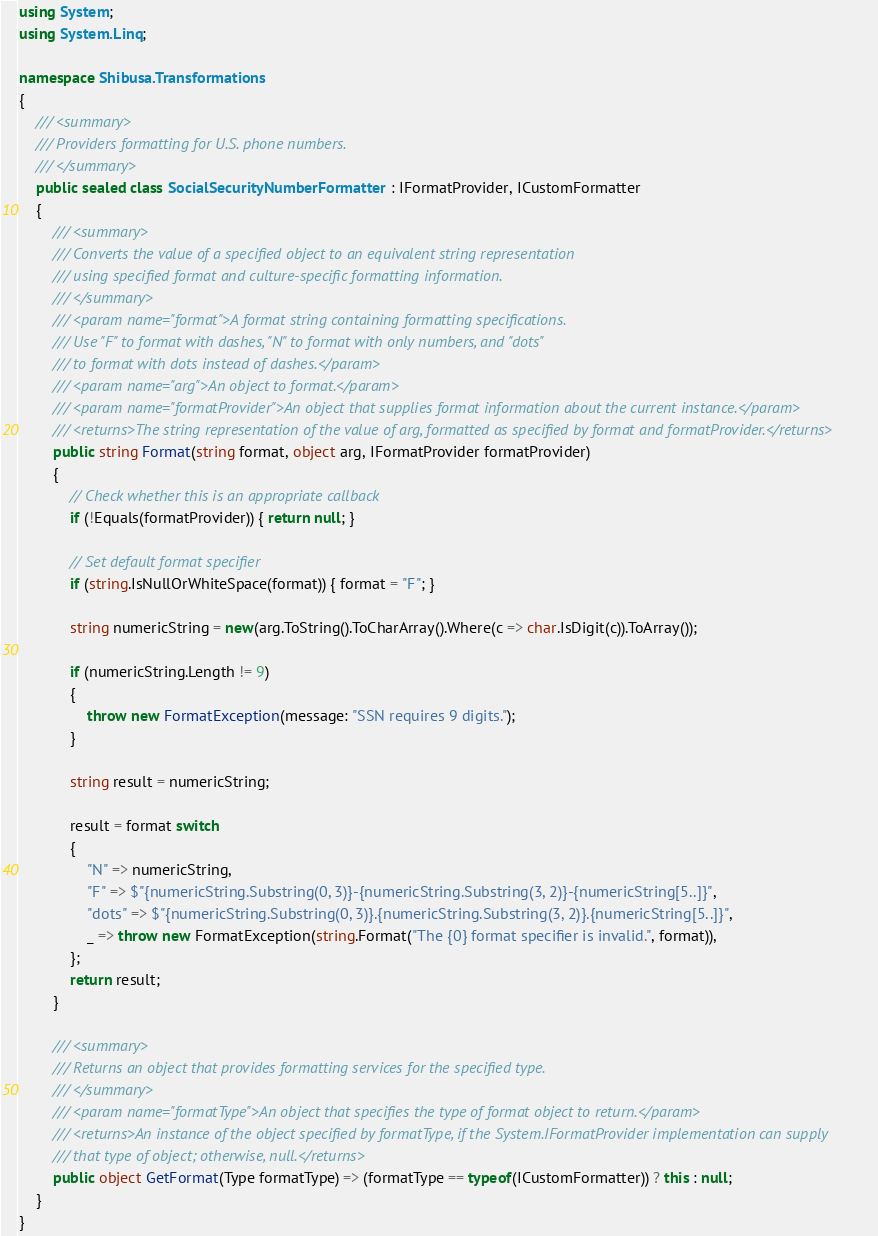<code> <loc_0><loc_0><loc_500><loc_500><_C#_>using System;
using System.Linq;

namespace Shibusa.Transformations
{
    /// <summary>
    /// Providers formatting for U.S. phone numbers.
    /// </summary>
    public sealed class SocialSecurityNumberFormatter : IFormatProvider, ICustomFormatter
    {
        /// <summary>
        /// Converts the value of a specified object to an equivalent string representation 
        /// using specified format and culture-specific formatting information.
        /// </summary>
        /// <param name="format">A format string containing formatting specifications.
        /// Use "F" to format with dashes, "N" to format with only numbers, and "dots"
        /// to format with dots instead of dashes.</param>
        /// <param name="arg">An object to format.</param>
        /// <param name="formatProvider">An object that supplies format information about the current instance.</param>
        /// <returns>The string representation of the value of arg, formatted as specified by format and formatProvider.</returns>
        public string Format(string format, object arg, IFormatProvider formatProvider)
        {
            // Check whether this is an appropriate callback             
            if (!Equals(formatProvider)) { return null; }

            // Set default format specifier             
            if (string.IsNullOrWhiteSpace(format)) { format = "F"; }

            string numericString = new(arg.ToString().ToCharArray().Where(c => char.IsDigit(c)).ToArray());

            if (numericString.Length != 9)
            {
                throw new FormatException(message: "SSN requires 9 digits.");
            }

            string result = numericString;

            result = format switch
            {
                "N" => numericString,
                "F" => $"{numericString.Substring(0, 3)}-{numericString.Substring(3, 2)}-{numericString[5..]}",
                "dots" => $"{numericString.Substring(0, 3)}.{numericString.Substring(3, 2)}.{numericString[5..]}",
                _ => throw new FormatException(string.Format("The {0} format specifier is invalid.", format)),
            };
            return result;
        }

        /// <summary>
        /// Returns an object that provides formatting services for the specified type.
        /// </summary>
        /// <param name="formatType">An object that specifies the type of format object to return.</param>
        /// <returns>An instance of the object specified by formatType, if the System.IFormatProvider implementation can supply
        /// that type of object; otherwise, null.</returns>
        public object GetFormat(Type formatType) => (formatType == typeof(ICustomFormatter)) ? this : null;
    }
}
</code> 